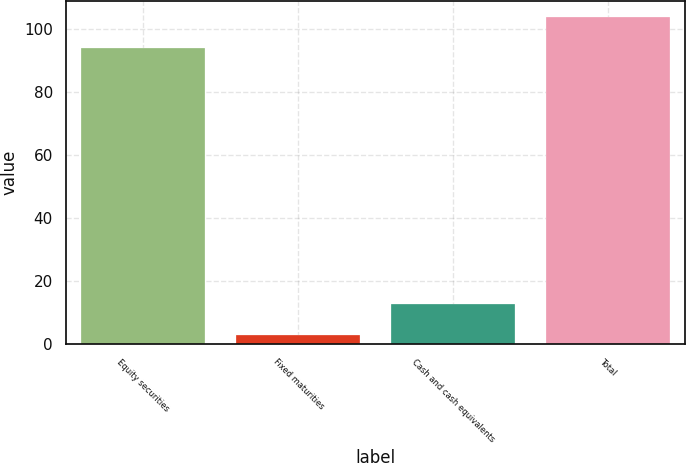Convert chart. <chart><loc_0><loc_0><loc_500><loc_500><bar_chart><fcel>Equity securities<fcel>Fixed maturities<fcel>Cash and cash equivalents<fcel>Total<nl><fcel>94<fcel>3<fcel>12.7<fcel>103.7<nl></chart> 